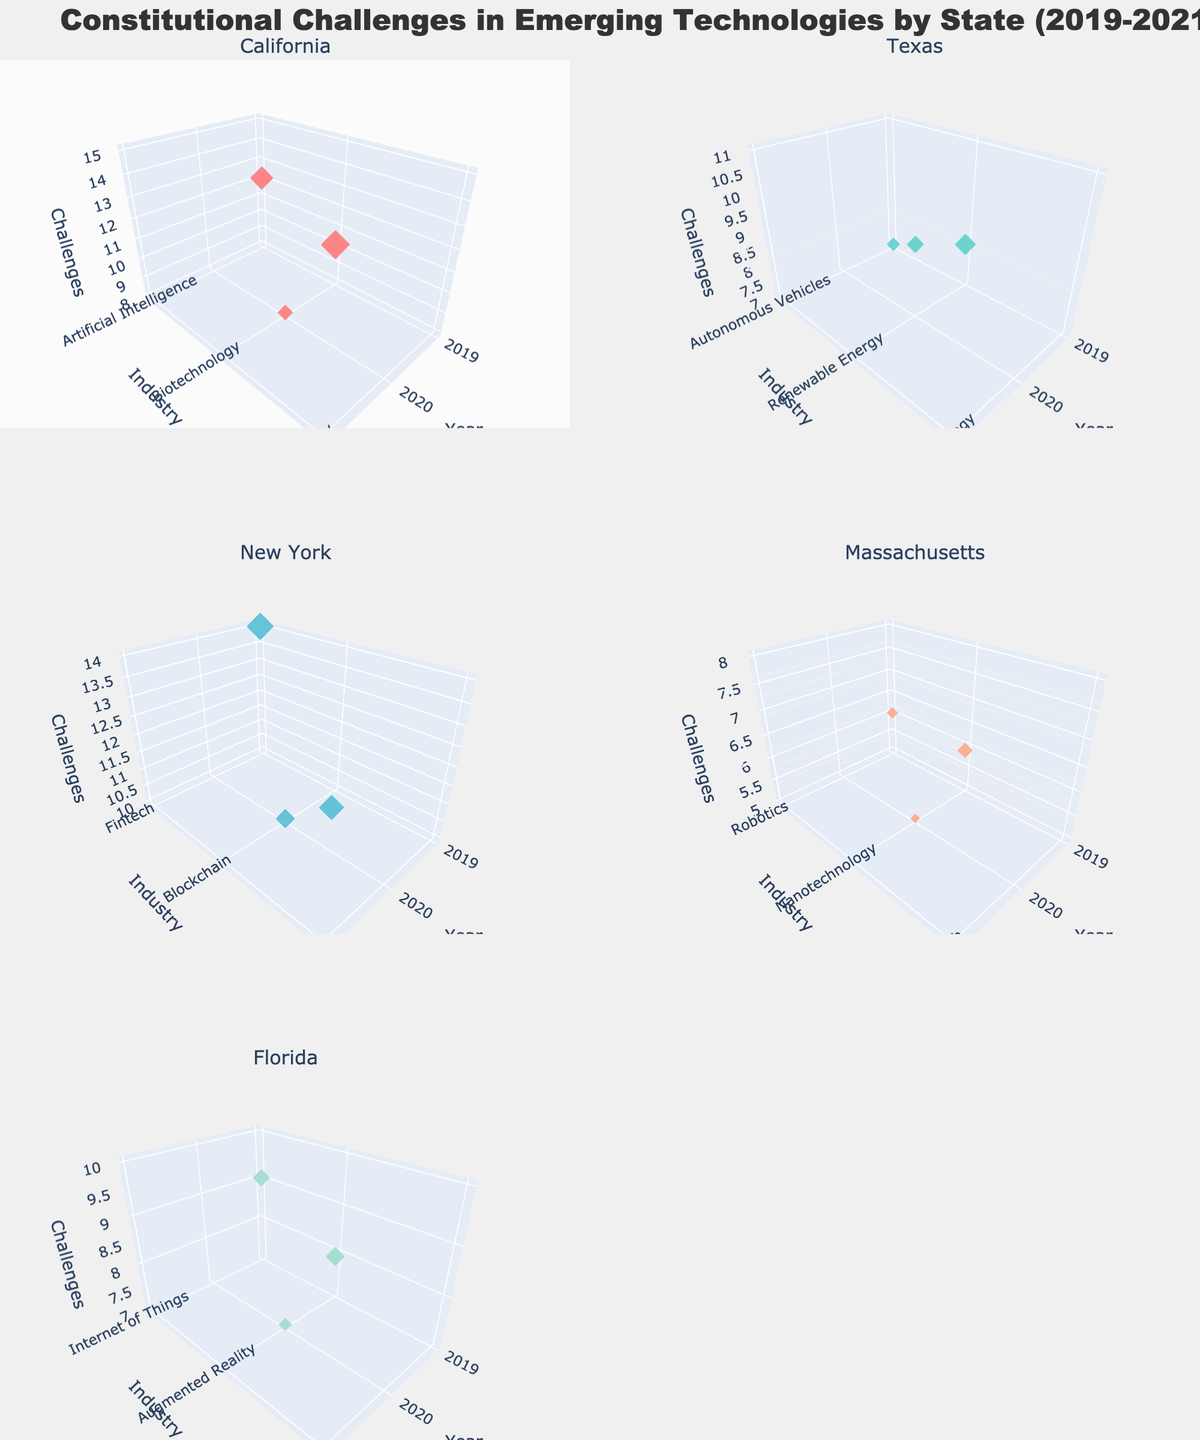What's the total number of constitutional challenges in California across all industries in 2021? Summing up the number of constitutional challenges for each industry in California in 2021, there is only one relevant entry for Cybersecurity with 15 challenges.
Answer: 15 Which state had the highest number of challenges in the Fintech industry in 2019? The subplot titled "New York" shows that the Fintech industry had 14 challenges in 2019, which is higher than any other Fintech challenges shown.
Answer: New York What can you tell about the industry with the most challenges in Texas? From the Texas subplot, comparing the maximum value on the Z-axis for 2019 (Autonomous Vehicles - 7), 2020 (Renewable Energy - 9), and 2021 (Space Technology - 11), Space Technology in 2021 has the highest number with 11 challenges.
Answer: Space Technology (2021) How does the number of challenges in the Digital Health industry in Massachusetts in 2021 compare to the number of challenges in the Nanotechnology industry in 2020? The Massachusetts subplot shows Digital Health in 2021 with 8 challenges, and Nanotechnology in 2020 with 5 challenges. 8 is greater than 5, so Digital Health had more challenges.
Answer: 8 is greater than 5 Are any states represented in all the subplots? By examining all subplots titled by state, California, Texas, New York, Massachusetts, and Florida all appear in their respective scenes. No state appears in more than one subplot.
Answer: No Identify the industry with the least challenges in Florida in 2020 and state the number. From the Florida subplot in 2020, the industries Augmented Reality has 7 challenges, which is the least compared to other listed industries in the same year.
Answer: Augmented Reality, 7 challenges What's the average number of constitutional challenges in New York in 2021 across all industries? The New York subplot shows industries in 2021: 5G Networks with 13 challenges. Since it's the only industry listed for New York in 2021, the average is directly 13.
Answer: 13 How does the frequency of challenges in California compare between 2019 and 2020? The California subplot shows 12 challenges for Artificial Intelligence in 2019, and 8 challenges for Biotechnology in 2020. Thus, 12 is greater than 8.
Answer: 12 is greater than 8 What's the difference in the number of challenges between the Fintech industry in New York and the Internet of Things industry in Florida in 2019? The number of challenges in Fintech (New York) is 14 and in Internet of Things (Florida) is 9 in 2019. The difference is \( 14 - 9 = 5 \).
Answer: 5 What industry had the most constitutional challenges in California in 2019? The California subplot shows the year 2019 with Artificial Intelligence having 12 challenges, which is the only industry listed for that year.
Answer: Artificial Intelligence 